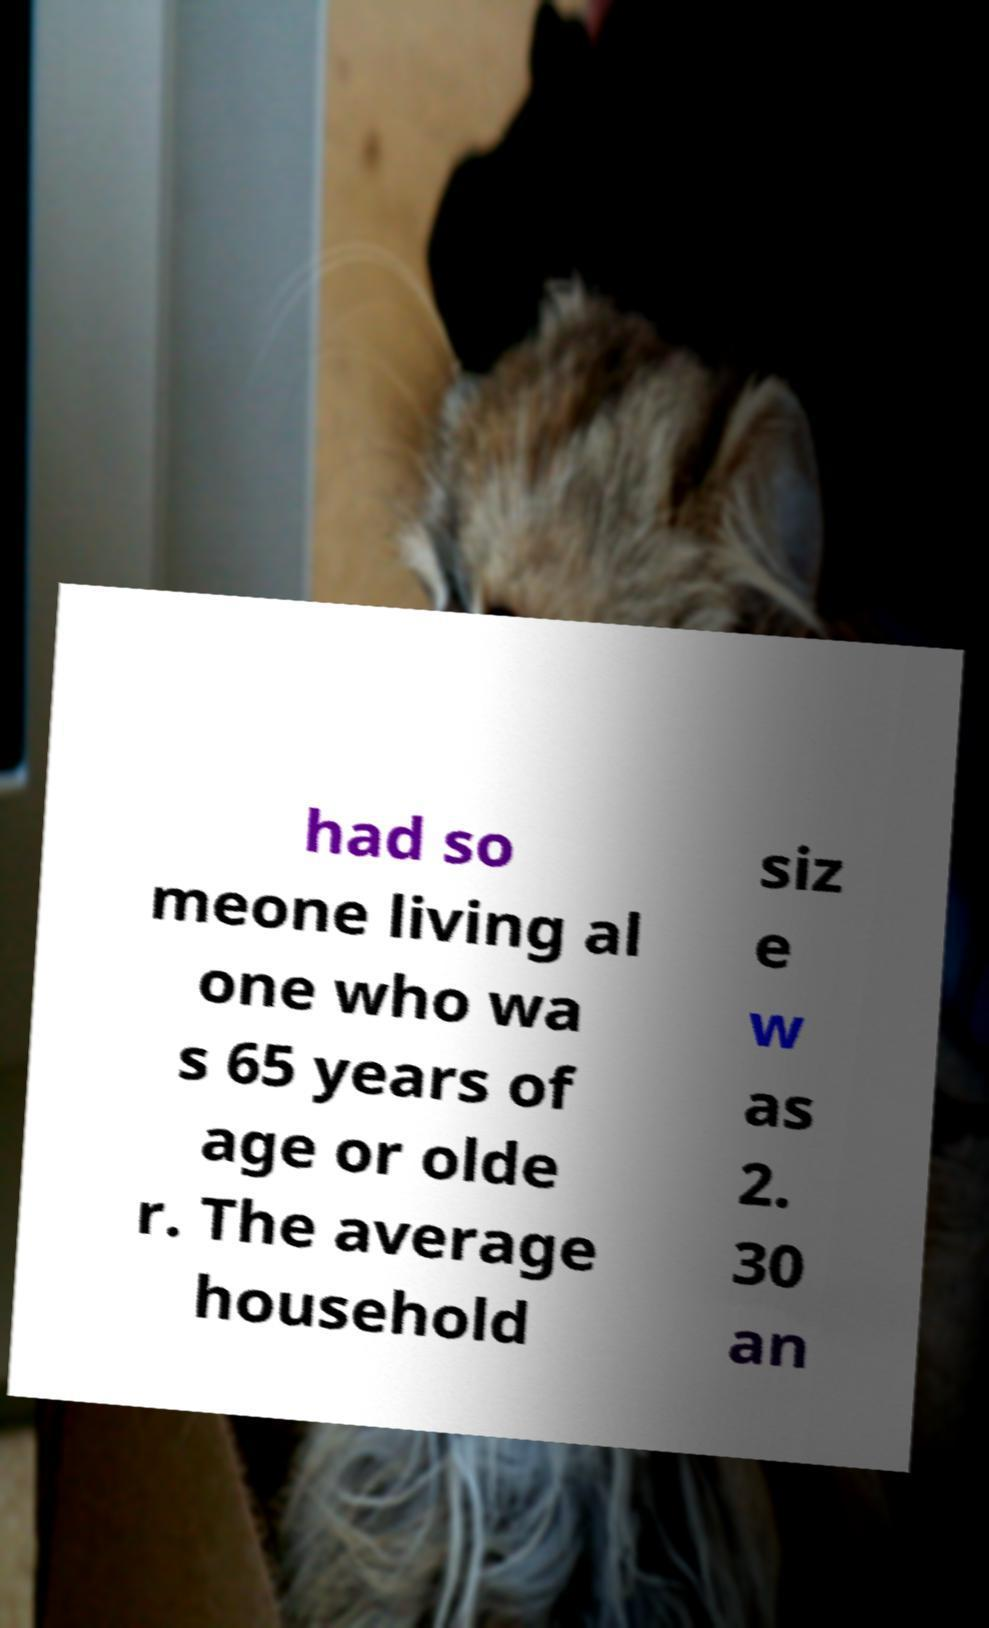Can you accurately transcribe the text from the provided image for me? had so meone living al one who wa s 65 years of age or olde r. The average household siz e w as 2. 30 an 